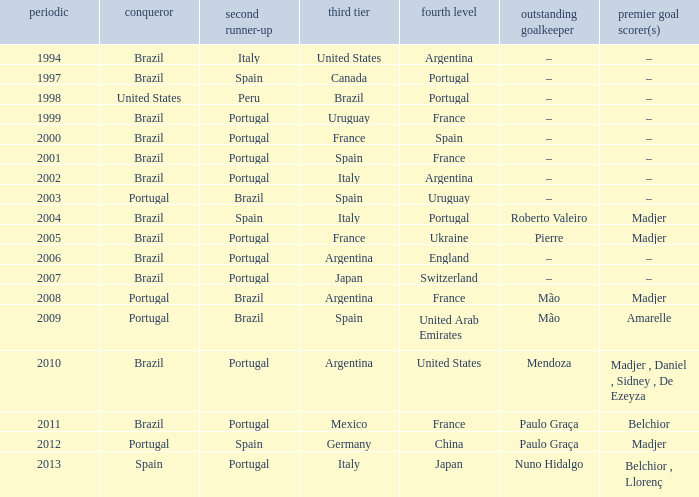What year was the runner-up Portugal with Italy in third place, and the gold keeper Nuno Hidalgo? 2013.0. 